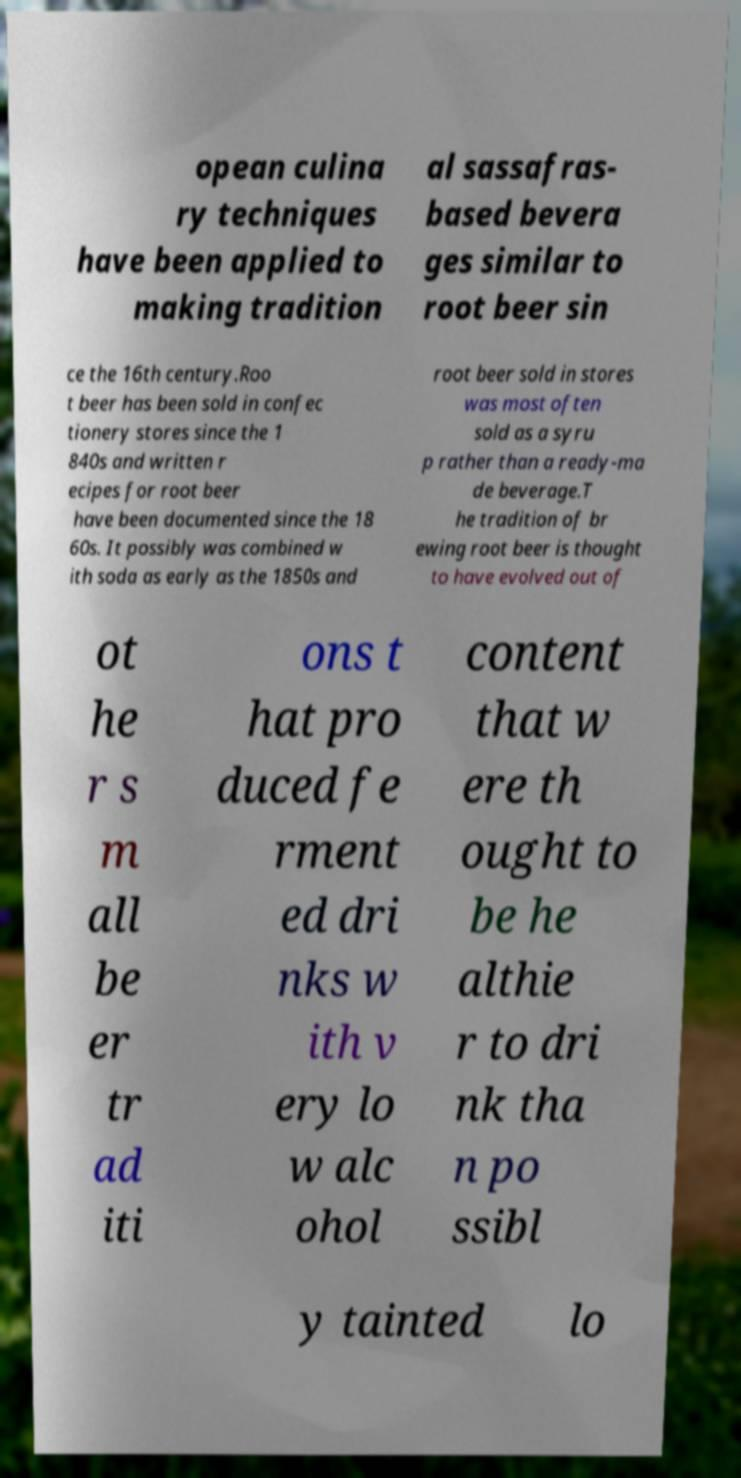Can you accurately transcribe the text from the provided image for me? opean culina ry techniques have been applied to making tradition al sassafras- based bevera ges similar to root beer sin ce the 16th century.Roo t beer has been sold in confec tionery stores since the 1 840s and written r ecipes for root beer have been documented since the 18 60s. It possibly was combined w ith soda as early as the 1850s and root beer sold in stores was most often sold as a syru p rather than a ready-ma de beverage.T he tradition of br ewing root beer is thought to have evolved out of ot he r s m all be er tr ad iti ons t hat pro duced fe rment ed dri nks w ith v ery lo w alc ohol content that w ere th ought to be he althie r to dri nk tha n po ssibl y tainted lo 